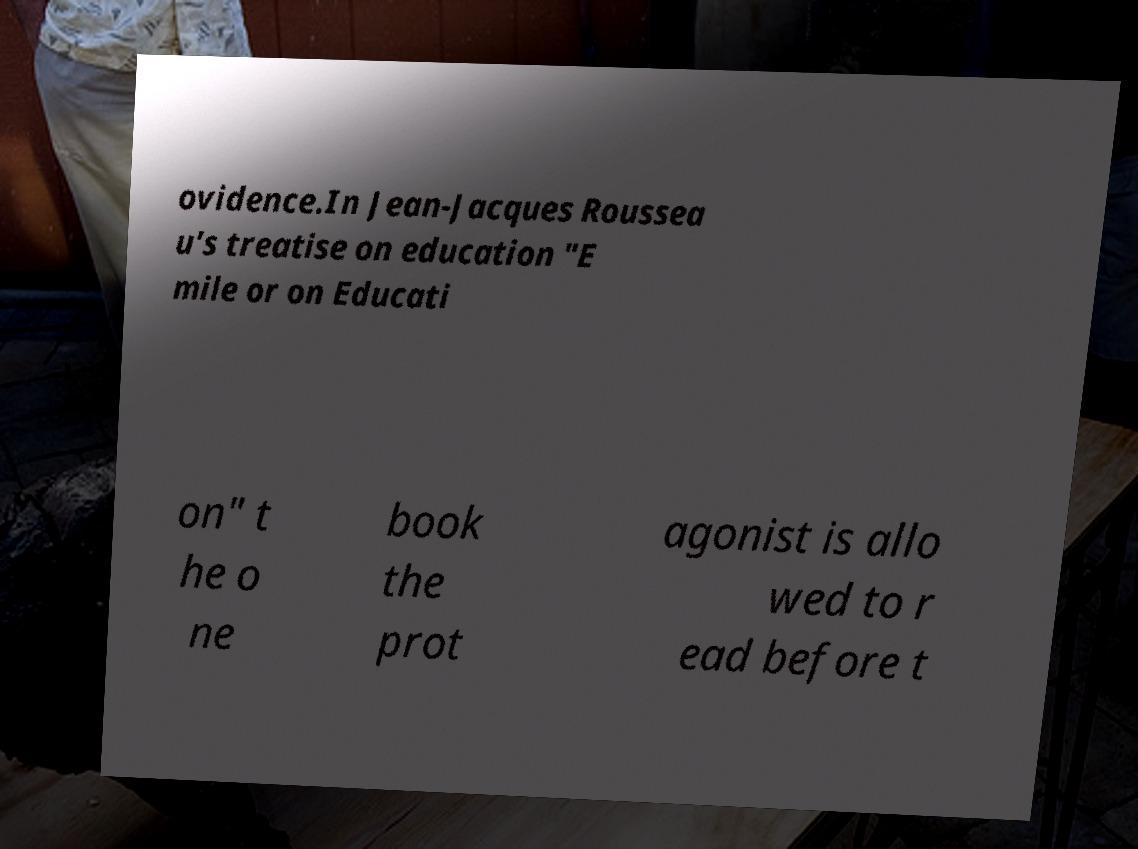Please read and relay the text visible in this image. What does it say? ovidence.In Jean-Jacques Roussea u's treatise on education "E mile or on Educati on" t he o ne book the prot agonist is allo wed to r ead before t 